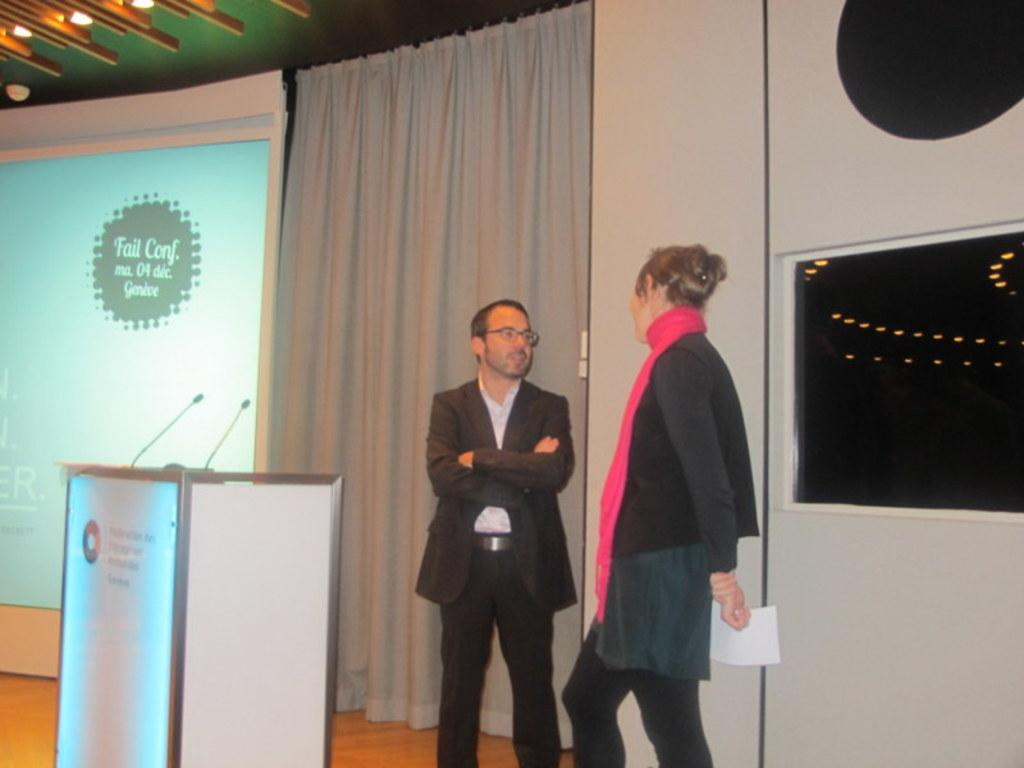Provide a one-sentence caption for the provided image. A man an woman chat near the podium of the Fail Conference. 